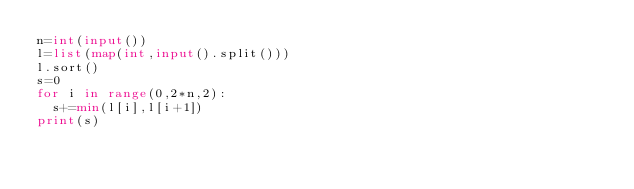Convert code to text. <code><loc_0><loc_0><loc_500><loc_500><_Python_>n=int(input())
l=list(map(int,input().split()))
l.sort()
s=0
for i in range(0,2*n,2):
  s+=min(l[i],l[i+1])
print(s)</code> 